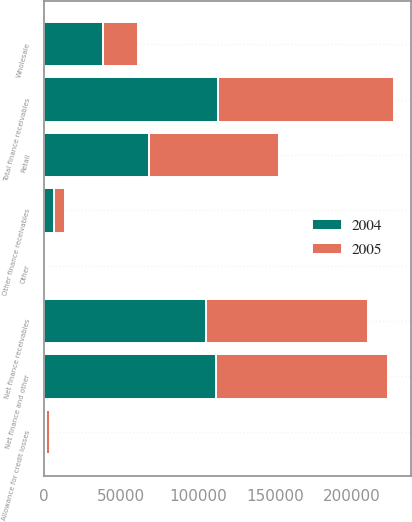Convert chart to OTSL. <chart><loc_0><loc_0><loc_500><loc_500><stacked_bar_chart><ecel><fcel>Retail<fcel>Wholesale<fcel>Other finance receivables<fcel>Total finance receivables<fcel>Allowance for credit losses<fcel>Other<fcel>Net finance and other<fcel>Net finance receivables<nl><fcel>2004<fcel>67928<fcel>38522<fcel>6320<fcel>112770<fcel>1400<fcel>66<fcel>111436<fcel>105481<nl><fcel>2005<fcel>84843<fcel>22666<fcel>7096<fcel>114605<fcel>2136<fcel>72<fcel>112541<fcel>104874<nl></chart> 